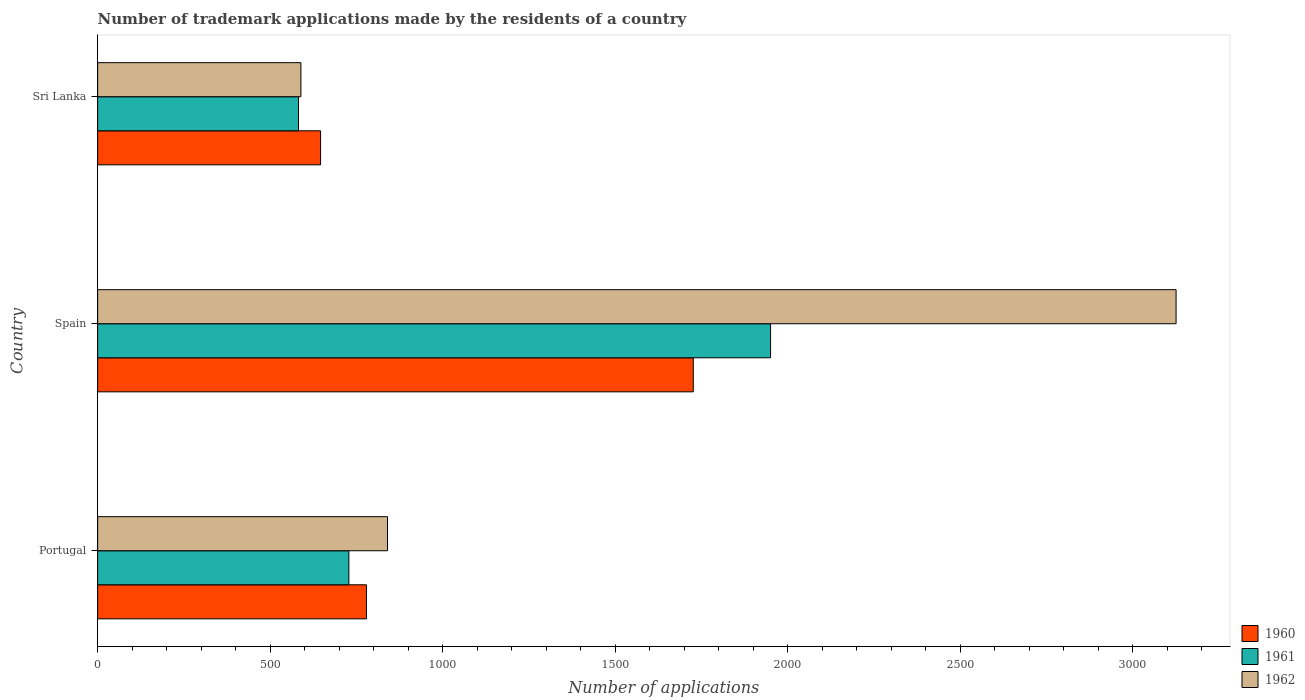How many different coloured bars are there?
Give a very brief answer. 3. Are the number of bars on each tick of the Y-axis equal?
Keep it short and to the point. Yes. What is the label of the 3rd group of bars from the top?
Your response must be concise. Portugal. What is the number of trademark applications made by the residents in 1960 in Spain?
Your response must be concise. 1726. Across all countries, what is the maximum number of trademark applications made by the residents in 1961?
Keep it short and to the point. 1950. Across all countries, what is the minimum number of trademark applications made by the residents in 1962?
Your response must be concise. 589. In which country was the number of trademark applications made by the residents in 1960 minimum?
Make the answer very short. Sri Lanka. What is the total number of trademark applications made by the residents in 1961 in the graph?
Make the answer very short. 3260. What is the difference between the number of trademark applications made by the residents in 1961 in Portugal and that in Spain?
Your answer should be compact. -1222. What is the difference between the number of trademark applications made by the residents in 1961 in Spain and the number of trademark applications made by the residents in 1962 in Portugal?
Provide a succinct answer. 1110. What is the average number of trademark applications made by the residents in 1960 per country?
Make the answer very short. 1050.33. What is the difference between the number of trademark applications made by the residents in 1962 and number of trademark applications made by the residents in 1961 in Sri Lanka?
Ensure brevity in your answer.  7. What is the ratio of the number of trademark applications made by the residents in 1961 in Portugal to that in Sri Lanka?
Ensure brevity in your answer.  1.25. Is the number of trademark applications made by the residents in 1962 in Portugal less than that in Spain?
Keep it short and to the point. Yes. What is the difference between the highest and the second highest number of trademark applications made by the residents in 1962?
Offer a very short reply. 2285. What is the difference between the highest and the lowest number of trademark applications made by the residents in 1962?
Your response must be concise. 2536. In how many countries, is the number of trademark applications made by the residents in 1961 greater than the average number of trademark applications made by the residents in 1961 taken over all countries?
Your response must be concise. 1. What does the 3rd bar from the top in Spain represents?
Ensure brevity in your answer.  1960. Is it the case that in every country, the sum of the number of trademark applications made by the residents in 1961 and number of trademark applications made by the residents in 1960 is greater than the number of trademark applications made by the residents in 1962?
Provide a succinct answer. Yes. Are all the bars in the graph horizontal?
Make the answer very short. Yes. How many countries are there in the graph?
Keep it short and to the point. 3. What is the difference between two consecutive major ticks on the X-axis?
Keep it short and to the point. 500. Are the values on the major ticks of X-axis written in scientific E-notation?
Keep it short and to the point. No. Does the graph contain any zero values?
Your response must be concise. No. How many legend labels are there?
Offer a very short reply. 3. How are the legend labels stacked?
Offer a terse response. Vertical. What is the title of the graph?
Make the answer very short. Number of trademark applications made by the residents of a country. Does "1979" appear as one of the legend labels in the graph?
Ensure brevity in your answer.  No. What is the label or title of the X-axis?
Provide a succinct answer. Number of applications. What is the Number of applications in 1960 in Portugal?
Offer a very short reply. 779. What is the Number of applications in 1961 in Portugal?
Give a very brief answer. 728. What is the Number of applications in 1962 in Portugal?
Keep it short and to the point. 840. What is the Number of applications in 1960 in Spain?
Give a very brief answer. 1726. What is the Number of applications in 1961 in Spain?
Keep it short and to the point. 1950. What is the Number of applications of 1962 in Spain?
Your response must be concise. 3125. What is the Number of applications in 1960 in Sri Lanka?
Your response must be concise. 646. What is the Number of applications in 1961 in Sri Lanka?
Your answer should be compact. 582. What is the Number of applications of 1962 in Sri Lanka?
Give a very brief answer. 589. Across all countries, what is the maximum Number of applications in 1960?
Make the answer very short. 1726. Across all countries, what is the maximum Number of applications of 1961?
Make the answer very short. 1950. Across all countries, what is the maximum Number of applications of 1962?
Provide a succinct answer. 3125. Across all countries, what is the minimum Number of applications in 1960?
Provide a short and direct response. 646. Across all countries, what is the minimum Number of applications in 1961?
Offer a terse response. 582. Across all countries, what is the minimum Number of applications in 1962?
Your answer should be compact. 589. What is the total Number of applications of 1960 in the graph?
Give a very brief answer. 3151. What is the total Number of applications of 1961 in the graph?
Offer a terse response. 3260. What is the total Number of applications in 1962 in the graph?
Offer a terse response. 4554. What is the difference between the Number of applications in 1960 in Portugal and that in Spain?
Make the answer very short. -947. What is the difference between the Number of applications of 1961 in Portugal and that in Spain?
Offer a terse response. -1222. What is the difference between the Number of applications of 1962 in Portugal and that in Spain?
Offer a terse response. -2285. What is the difference between the Number of applications in 1960 in Portugal and that in Sri Lanka?
Provide a short and direct response. 133. What is the difference between the Number of applications in 1961 in Portugal and that in Sri Lanka?
Provide a short and direct response. 146. What is the difference between the Number of applications in 1962 in Portugal and that in Sri Lanka?
Provide a short and direct response. 251. What is the difference between the Number of applications of 1960 in Spain and that in Sri Lanka?
Your response must be concise. 1080. What is the difference between the Number of applications in 1961 in Spain and that in Sri Lanka?
Your answer should be very brief. 1368. What is the difference between the Number of applications in 1962 in Spain and that in Sri Lanka?
Make the answer very short. 2536. What is the difference between the Number of applications in 1960 in Portugal and the Number of applications in 1961 in Spain?
Make the answer very short. -1171. What is the difference between the Number of applications of 1960 in Portugal and the Number of applications of 1962 in Spain?
Ensure brevity in your answer.  -2346. What is the difference between the Number of applications in 1961 in Portugal and the Number of applications in 1962 in Spain?
Your answer should be compact. -2397. What is the difference between the Number of applications of 1960 in Portugal and the Number of applications of 1961 in Sri Lanka?
Offer a terse response. 197. What is the difference between the Number of applications in 1960 in Portugal and the Number of applications in 1962 in Sri Lanka?
Give a very brief answer. 190. What is the difference between the Number of applications in 1961 in Portugal and the Number of applications in 1962 in Sri Lanka?
Ensure brevity in your answer.  139. What is the difference between the Number of applications of 1960 in Spain and the Number of applications of 1961 in Sri Lanka?
Offer a terse response. 1144. What is the difference between the Number of applications in 1960 in Spain and the Number of applications in 1962 in Sri Lanka?
Provide a succinct answer. 1137. What is the difference between the Number of applications of 1961 in Spain and the Number of applications of 1962 in Sri Lanka?
Keep it short and to the point. 1361. What is the average Number of applications in 1960 per country?
Your answer should be very brief. 1050.33. What is the average Number of applications of 1961 per country?
Provide a succinct answer. 1086.67. What is the average Number of applications in 1962 per country?
Provide a short and direct response. 1518. What is the difference between the Number of applications of 1960 and Number of applications of 1962 in Portugal?
Provide a succinct answer. -61. What is the difference between the Number of applications in 1961 and Number of applications in 1962 in Portugal?
Make the answer very short. -112. What is the difference between the Number of applications in 1960 and Number of applications in 1961 in Spain?
Provide a succinct answer. -224. What is the difference between the Number of applications in 1960 and Number of applications in 1962 in Spain?
Offer a very short reply. -1399. What is the difference between the Number of applications in 1961 and Number of applications in 1962 in Spain?
Keep it short and to the point. -1175. What is the difference between the Number of applications in 1960 and Number of applications in 1961 in Sri Lanka?
Keep it short and to the point. 64. What is the ratio of the Number of applications of 1960 in Portugal to that in Spain?
Offer a very short reply. 0.45. What is the ratio of the Number of applications in 1961 in Portugal to that in Spain?
Your response must be concise. 0.37. What is the ratio of the Number of applications of 1962 in Portugal to that in Spain?
Your answer should be compact. 0.27. What is the ratio of the Number of applications in 1960 in Portugal to that in Sri Lanka?
Your response must be concise. 1.21. What is the ratio of the Number of applications in 1961 in Portugal to that in Sri Lanka?
Your answer should be compact. 1.25. What is the ratio of the Number of applications of 1962 in Portugal to that in Sri Lanka?
Ensure brevity in your answer.  1.43. What is the ratio of the Number of applications in 1960 in Spain to that in Sri Lanka?
Offer a very short reply. 2.67. What is the ratio of the Number of applications in 1961 in Spain to that in Sri Lanka?
Provide a short and direct response. 3.35. What is the ratio of the Number of applications in 1962 in Spain to that in Sri Lanka?
Make the answer very short. 5.31. What is the difference between the highest and the second highest Number of applications in 1960?
Provide a succinct answer. 947. What is the difference between the highest and the second highest Number of applications in 1961?
Your response must be concise. 1222. What is the difference between the highest and the second highest Number of applications of 1962?
Give a very brief answer. 2285. What is the difference between the highest and the lowest Number of applications of 1960?
Keep it short and to the point. 1080. What is the difference between the highest and the lowest Number of applications of 1961?
Provide a short and direct response. 1368. What is the difference between the highest and the lowest Number of applications in 1962?
Your answer should be compact. 2536. 